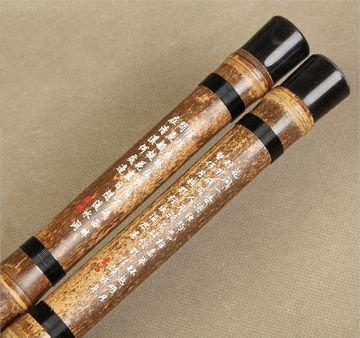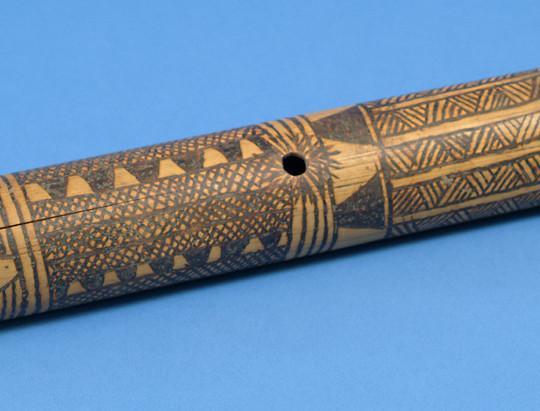The first image is the image on the left, the second image is the image on the right. Evaluate the accuracy of this statement regarding the images: "There are two flutes in the left image.". Is it true? Answer yes or no. Yes. The first image is the image on the left, the second image is the image on the right. Analyze the images presented: Is the assertion "One image shows two diagonally displayed, side-by-side wooden flutes, and the other image shows at least one hole in a single wooden flute." valid? Answer yes or no. Yes. 